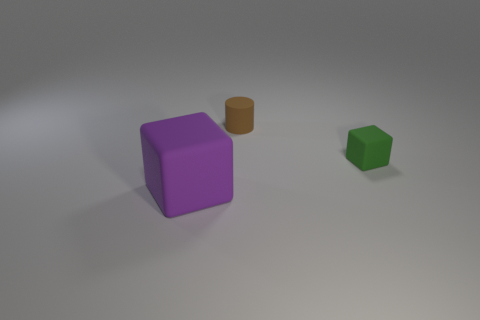Is there anything else that is the same material as the tiny green thing?
Give a very brief answer. Yes. There is another object that is the same shape as the green thing; what size is it?
Your answer should be very brief. Large. There is a rubber object that is to the right of the purple block and to the left of the green block; what is its color?
Provide a short and direct response. Brown. Is the small green object made of the same material as the tiny object that is behind the green object?
Your answer should be very brief. Yes. Is the number of tiny cylinders that are left of the brown rubber cylinder less than the number of tiny brown cylinders?
Offer a terse response. Yes. How many other things are there of the same shape as the brown thing?
Your answer should be compact. 0. Are there any other things that have the same color as the small cylinder?
Give a very brief answer. No. There is a big object; does it have the same color as the matte object behind the green thing?
Your response must be concise. No. What number of other objects are there of the same size as the cylinder?
Offer a very short reply. 1. What number of spheres are brown rubber things or big rubber objects?
Provide a short and direct response. 0. 